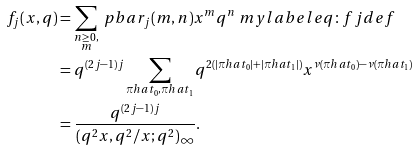Convert formula to latex. <formula><loc_0><loc_0><loc_500><loc_500>f _ { j } ( x , q ) & = \sum _ { \substack { n \geq 0 , \\ m } } \ p b a r _ { j } ( m , n ) x ^ { m } q ^ { n } \ m y l a b e l { e q \colon f j d e f } \\ & = q ^ { ( 2 j - 1 ) j } \sum _ { \pi h a t _ { 0 } , \pi h a t _ { 1 } } q ^ { 2 ( | \pi h a t _ { 0 } | + | \pi h a t _ { 1 } | ) } x ^ { \nu ( \pi h a t _ { 0 } ) - \nu ( \pi h a t _ { 1 } ) } \\ & = \frac { q ^ { ( 2 j - 1 ) j } } { ( q ^ { 2 } x , q ^ { 2 } / x ; q ^ { 2 } ) _ { \infty } } .</formula> 